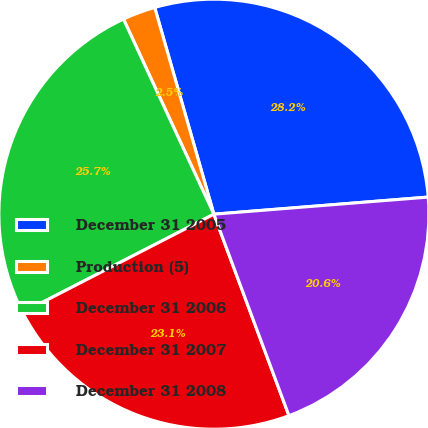<chart> <loc_0><loc_0><loc_500><loc_500><pie_chart><fcel>December 31 2005<fcel>Production (5)<fcel>December 31 2006<fcel>December 31 2007<fcel>December 31 2008<nl><fcel>28.17%<fcel>2.47%<fcel>25.65%<fcel>23.12%<fcel>20.59%<nl></chart> 